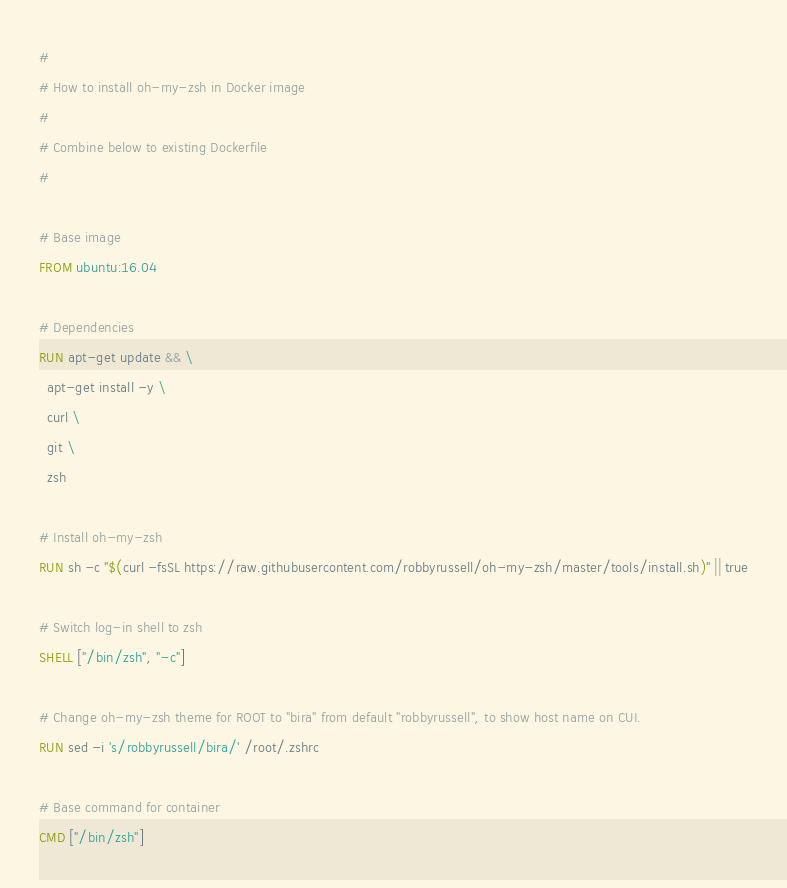<code> <loc_0><loc_0><loc_500><loc_500><_Dockerfile_>#
# How to install oh-my-zsh in Docker image
# 
# Combine below to existing Dockerfile
#

# Base image
FROM ubuntu:16.04

# Dependencies
RUN apt-get update && \
  apt-get install -y \
  curl \
  git \
  zsh

# Install oh-my-zsh
RUN sh -c "$(curl -fsSL https://raw.githubusercontent.com/robbyrussell/oh-my-zsh/master/tools/install.sh)" || true

# Switch log-in shell to zsh
SHELL ["/bin/zsh", "-c"]

# Change oh-my-zsh theme for ROOT to "bira" from default "robbyrussell", to show host name on CUI.
RUN sed -i 's/robbyrussell/bira/' /root/.zshrc

# Base command for container
CMD ["/bin/zsh"]


</code> 